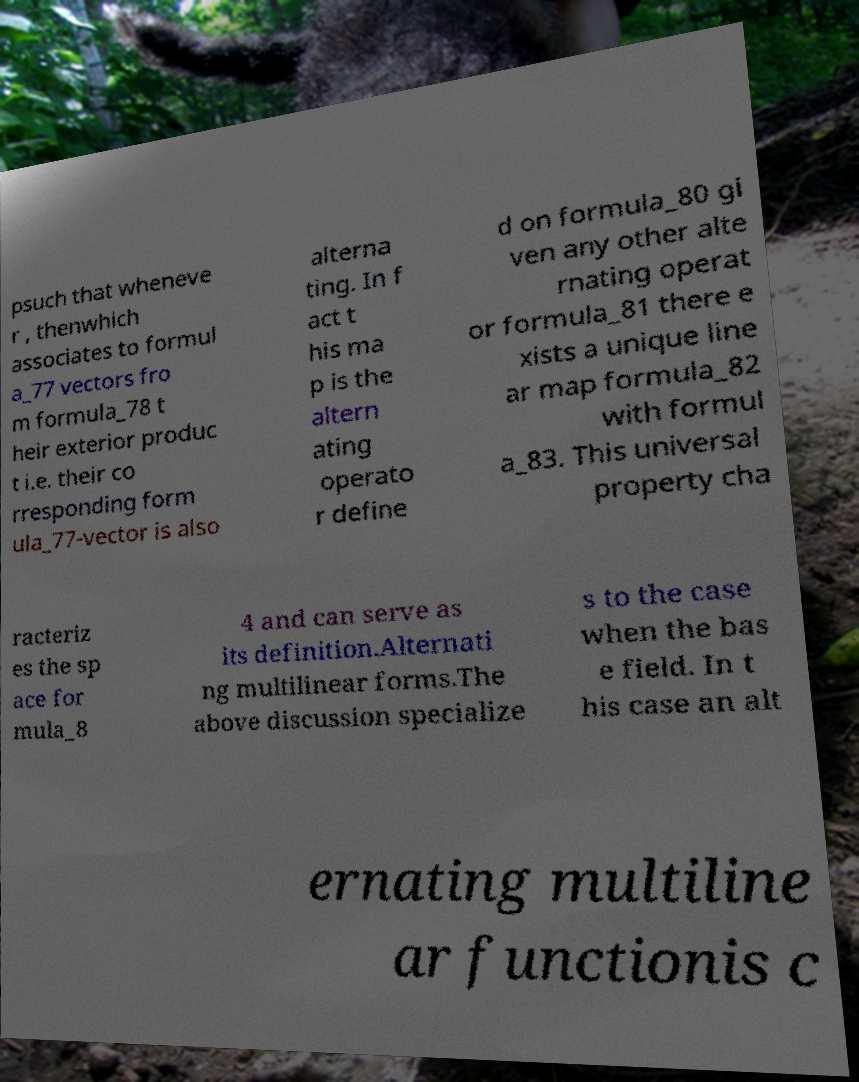Can you read and provide the text displayed in the image?This photo seems to have some interesting text. Can you extract and type it out for me? psuch that wheneve r , thenwhich associates to formul a_77 vectors fro m formula_78 t heir exterior produc t i.e. their co rresponding form ula_77-vector is also alterna ting. In f act t his ma p is the altern ating operato r define d on formula_80 gi ven any other alte rnating operat or formula_81 there e xists a unique line ar map formula_82 with formul a_83. This universal property cha racteriz es the sp ace for mula_8 4 and can serve as its definition.Alternati ng multilinear forms.The above discussion specialize s to the case when the bas e field. In t his case an alt ernating multiline ar functionis c 